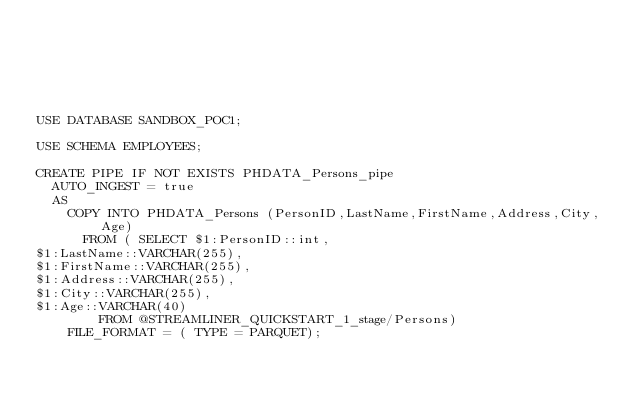Convert code to text. <code><loc_0><loc_0><loc_500><loc_500><_SQL_>





USE DATABASE SANDBOX_POC1;

USE SCHEMA EMPLOYEES;

CREATE PIPE IF NOT EXISTS PHDATA_Persons_pipe
	AUTO_INGEST = true
	AS
		COPY INTO PHDATA_Persons (PersonID,LastName,FirstName,Address,City,Age)
			FROM ( SELECT $1:PersonID::int,
$1:LastName::VARCHAR(255),
$1:FirstName::VARCHAR(255),
$1:Address::VARCHAR(255),
$1:City::VARCHAR(255),
$1:Age::VARCHAR(40)
				FROM @STREAMLINER_QUICKSTART_1_stage/Persons)
		FILE_FORMAT = ( TYPE = PARQUET);
</code> 